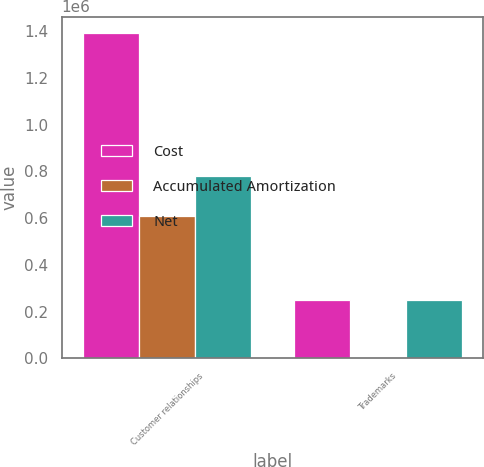Convert chart. <chart><loc_0><loc_0><loc_500><loc_500><stacked_bar_chart><ecel><fcel>Customer relationships<fcel>Trademarks<nl><fcel>Cost<fcel>1.39223e+06<fcel>249726<nl><fcel>Accumulated Amortization<fcel>610514<fcel>861<nl><fcel>Net<fcel>781717<fcel>248865<nl></chart> 